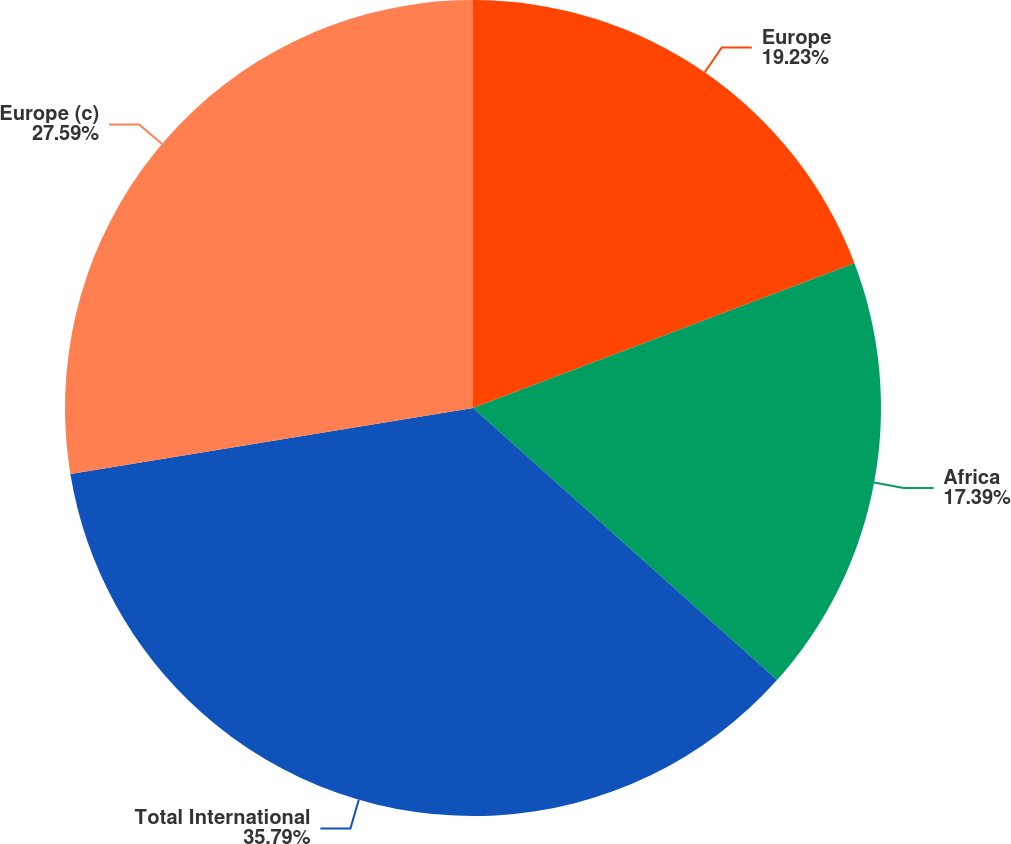<chart> <loc_0><loc_0><loc_500><loc_500><pie_chart><fcel>Europe<fcel>Africa<fcel>Total International<fcel>Europe (c)<nl><fcel>19.23%<fcel>17.39%<fcel>35.79%<fcel>27.59%<nl></chart> 